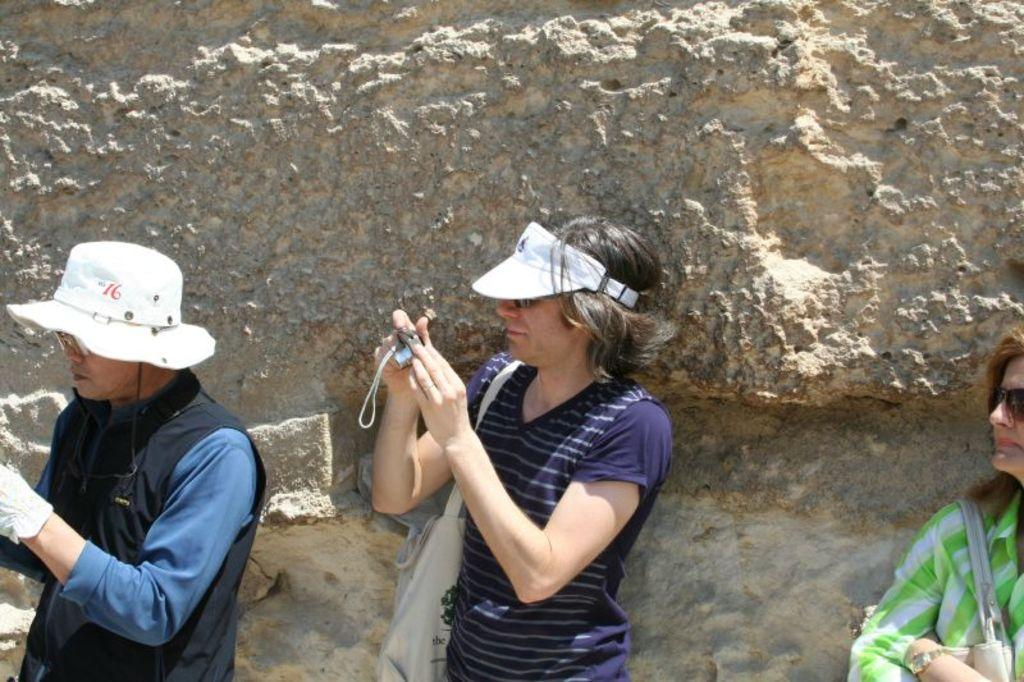How many people are in the image? There are three persons in the image. What is one person doing in the image? One person is holding a camera in their hand. What else can be seen on the person with the camera? The person with the camera is wearing a bag. What can be seen in the background of the image? There is a rock in the background of the image. What type of religious symbol can be seen on the rock in the image? There is no religious symbol present on the rock in the image. What type of machine is being used by the person with the camera? The person with the camera is not using a machine; they are simply holding a camera in their hand. 